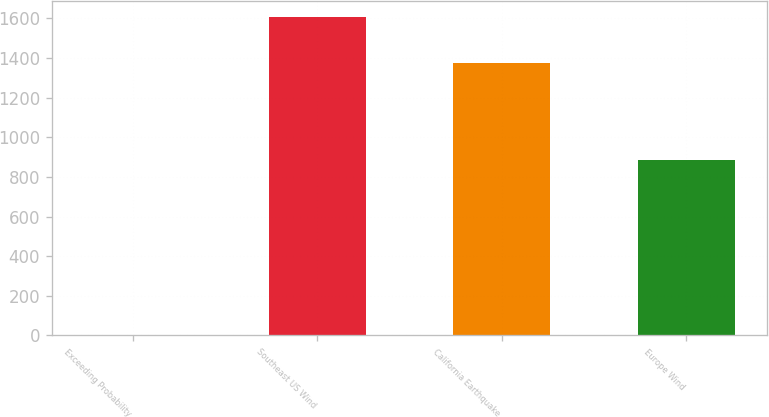<chart> <loc_0><loc_0><loc_500><loc_500><bar_chart><fcel>Exceeding Probability<fcel>Southeast US Wind<fcel>California Earthquake<fcel>Europe Wind<nl><fcel>0.4<fcel>1606<fcel>1377<fcel>883<nl></chart> 